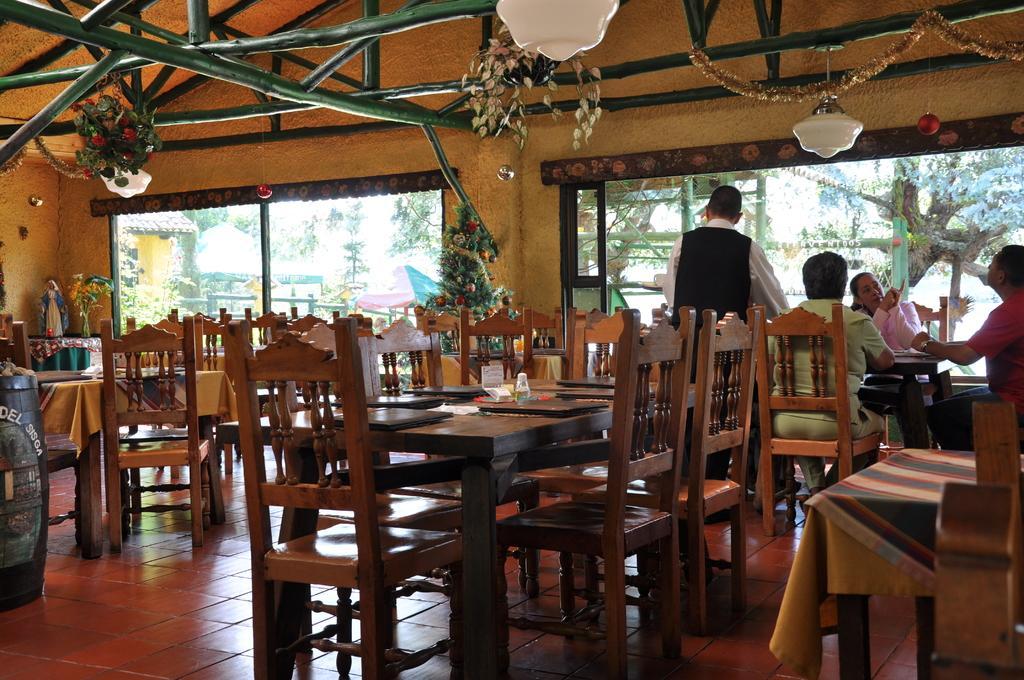Could you give a brief overview of what you see in this image? In the given image we can see the , there are many chairs and tables. There are seven persons sitting on chair, this is a plant and a window. 